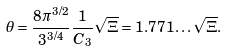Convert formula to latex. <formula><loc_0><loc_0><loc_500><loc_500>\theta = \frac { 8 \pi ^ { 3 / 2 } } { 3 ^ { 3 / 4 } } \frac { 1 } { C _ { 3 } } \sqrt { \Xi } = 1 . 7 7 1 \dots \sqrt { \Xi } .</formula> 